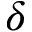<formula> <loc_0><loc_0><loc_500><loc_500>\delta</formula> 